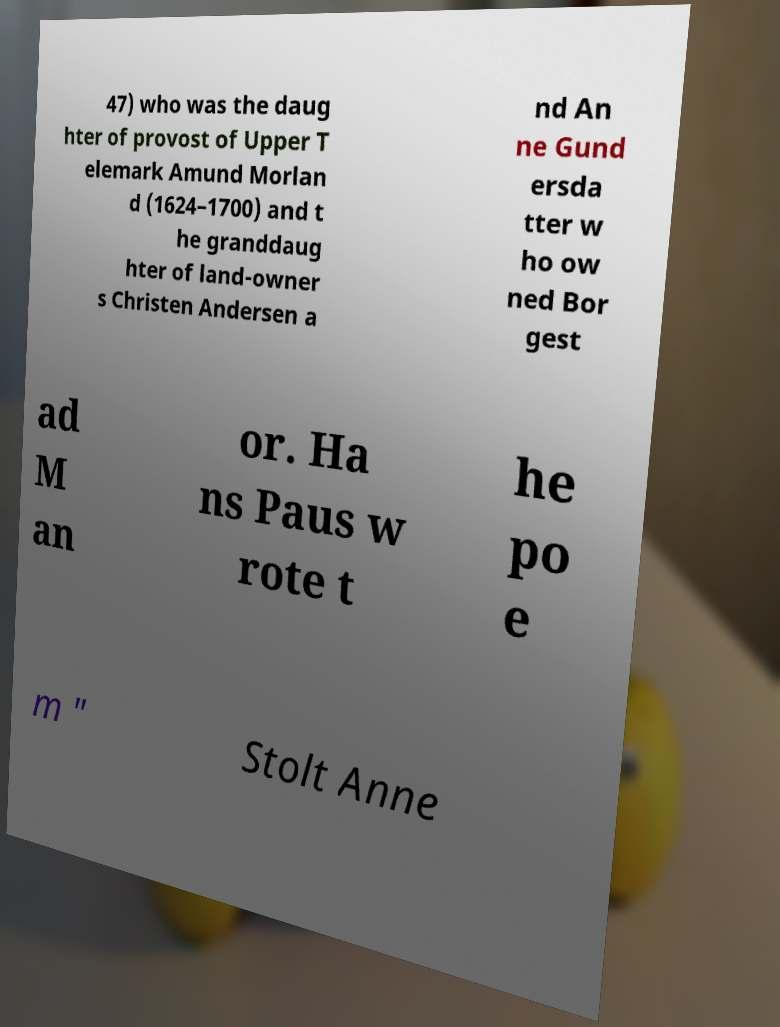Please identify and transcribe the text found in this image. 47) who was the daug hter of provost of Upper T elemark Amund Morlan d (1624–1700) and t he granddaug hter of land-owner s Christen Andersen a nd An ne Gund ersda tter w ho ow ned Bor gest ad M an or. Ha ns Paus w rote t he po e m " Stolt Anne 